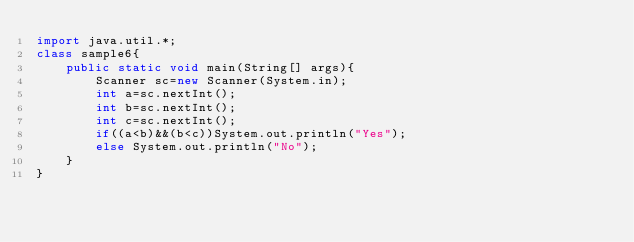<code> <loc_0><loc_0><loc_500><loc_500><_Java_>import java.util.*;
class sample6{
    public static void main(String[] args){
        Scanner sc=new Scanner(System.in);
        int a=sc.nextInt();
        int b=sc.nextInt();
        int c=sc.nextInt();
        if((a<b)&&(b<c))System.out.println("Yes");
        else System.out.println("No");
    }
}</code> 